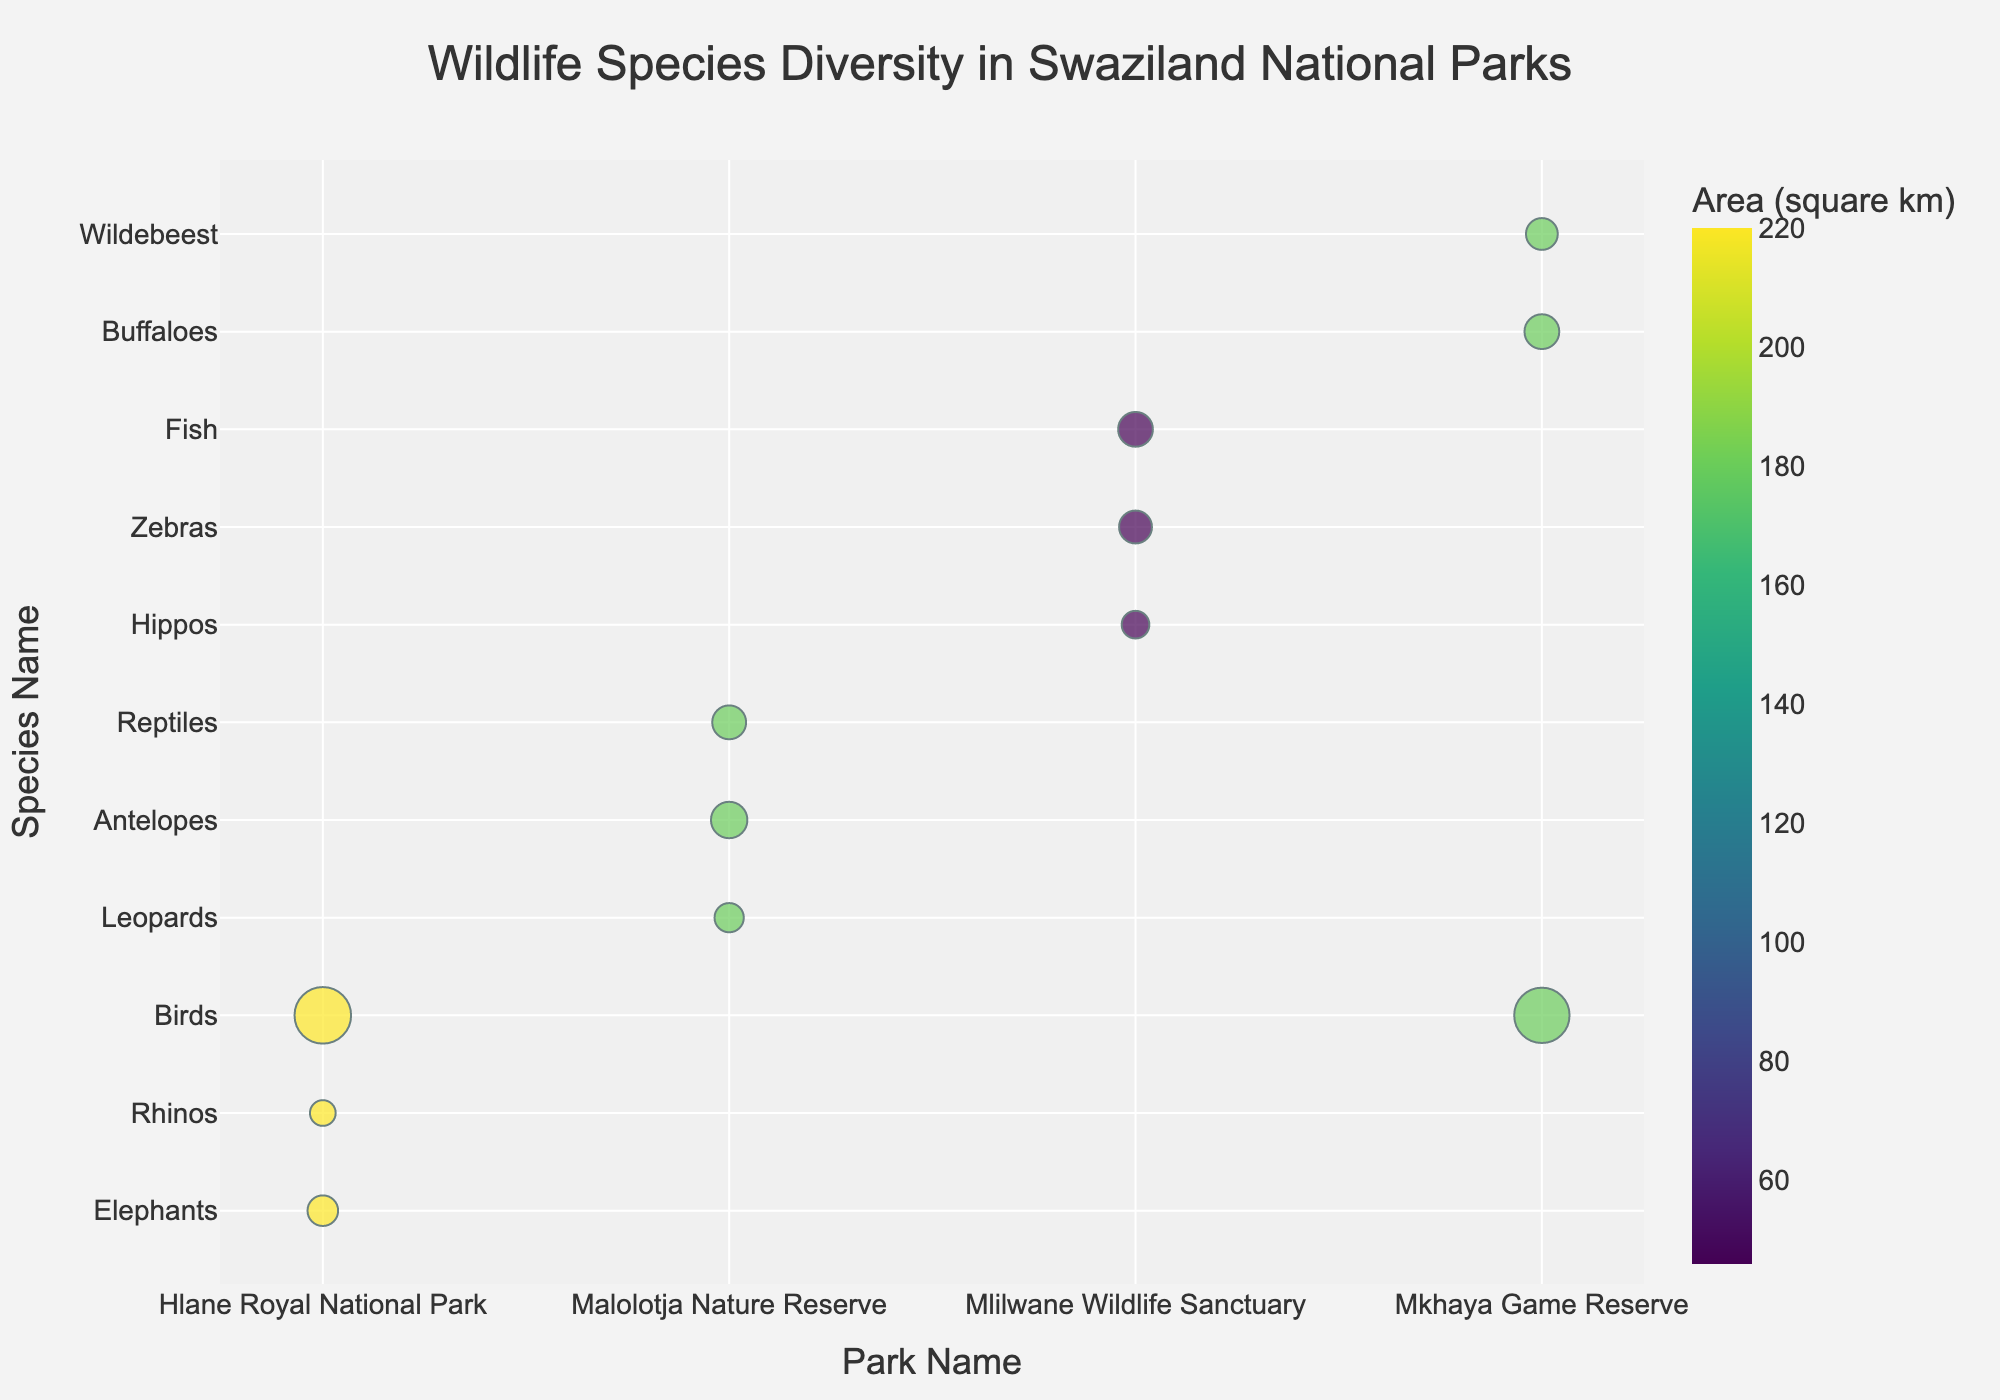What is the title of the chart? The title is usually displayed at the top of the chart in larger font size compared to other text. The title in this case is specified in the plot generation code.
Answer: Wildlife Species Diversity in Swaziland National Parks Which park has the highest number of bird species? Looking at the bubbles labeled on the Y-axis with species names, find the largest bubble corresponding to 'Birds'. The park name associated with this bubble on the X-axis is the answer.
Answer: Hlane Royal National Park What color is used to represent Mlilwane Wildlife Sanctuary? The color corresponds to the 'Area (square km)' and is reflected on the bubbles. Since Mlilwane Wildlife Sanctuary is the park with the smallest area (46 sq km), it will be the color representing the smallest categories. This color can be identified from the color scale bar on the side of the chart.
Answer: Light color (as per Viridis color scale) Which species has the largest bubble size in Mkhaya Game Reserve? Bubbles in Mkhaya Game Reserve are grouped under its name on the x-axis. The size of the bubble reflects the number of species. Identify the species name on the Y-axis with the largest bubble under Mkhaya Game Reserve.
Answer: Birds In which park are fish species monitored and how many species are there? Look through the species names on the Y-axis and identify where 'Fish' is listed. The corresponding park on the X-axis shows where they are monitored. The bubble size (or hover data) reveals the number of species.
Answer: Mlilwane Wildlife Sanctuary, 50 species How many species of reptiles are found in Malolotja Nature Reserve? Locate 'Reptiles' on the Y-axis under Malolotja Nature Reserve on the X-axis and read the corresponding number of species either directly from the chart or from the hover data.
Answer: 45 species What is the total number of species monitored in Hlane Royal National Park? Sum the number of species for each category (Elephants, Rhinos, Birds) under Hlane Royal National Park from the bubbles represented in the chart. 30 + 15 + 350 = 395.
Answer: 395 species Which park has the highest diversity in terms of the number of species categories? Count the number of unique species categories (Y-axis labels) represented by bubbles under each park (X-axis labels). The one with the most categories is the answer.
Answer: Hlane Royal National Park Which park has the most similar area size to Malolotja Nature Reserve and what species are found there? Compare the park areas and find the one closest to Malolotja Nature Reserve's 180 sq km. Compare data point-wise using the 'Area (square km)' hover data. Mkhaya Game Reserve has the same area. Check species names under it.
Answer: Mkhaya Game Reserve, species: Buffaloes, Wildebeest, Birds Which park has both large herbivores like Hippos and Zebras and what's their combined number of species? Look for dyads of Hippos and Zebras on the Y-axis and then locate their corresponding park on the X-axis. Add their number of species by referring to bubble sizes or hover data. 20 (Hippos) + 40 (Zebras) = 60.
Answer: Mlilwane Wildlife Sanctuary, 60 species 